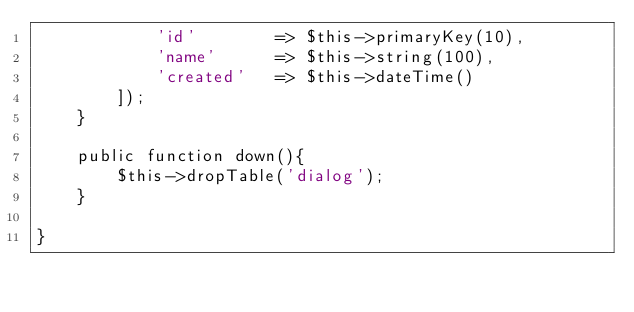Convert code to text. <code><loc_0><loc_0><loc_500><loc_500><_PHP_>            'id'        => $this->primaryKey(10),
            'name'      => $this->string(100),
            'created'   => $this->dateTime()
        ]);
    }

    public function down(){
        $this->dropTable('dialog');
    }

}
</code> 